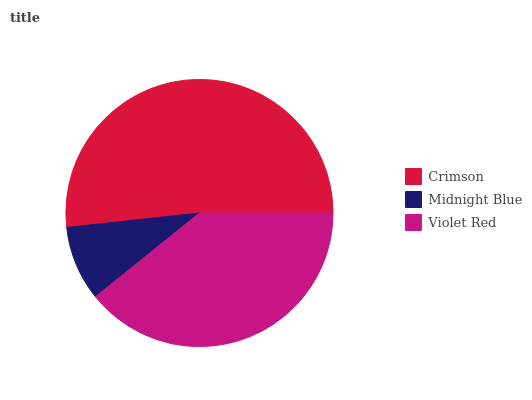Is Midnight Blue the minimum?
Answer yes or no. Yes. Is Crimson the maximum?
Answer yes or no. Yes. Is Violet Red the minimum?
Answer yes or no. No. Is Violet Red the maximum?
Answer yes or no. No. Is Violet Red greater than Midnight Blue?
Answer yes or no. Yes. Is Midnight Blue less than Violet Red?
Answer yes or no. Yes. Is Midnight Blue greater than Violet Red?
Answer yes or no. No. Is Violet Red less than Midnight Blue?
Answer yes or no. No. Is Violet Red the high median?
Answer yes or no. Yes. Is Violet Red the low median?
Answer yes or no. Yes. Is Midnight Blue the high median?
Answer yes or no. No. Is Crimson the low median?
Answer yes or no. No. 